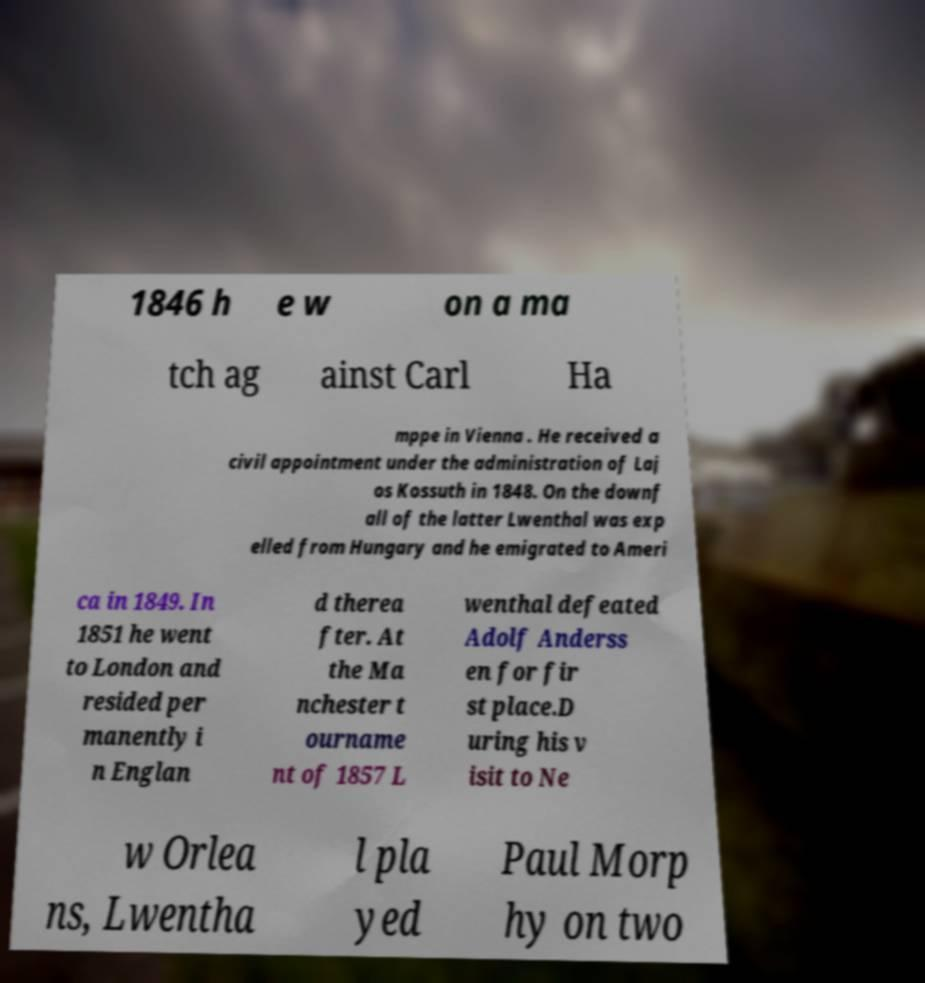Could you extract and type out the text from this image? 1846 h e w on a ma tch ag ainst Carl Ha mppe in Vienna . He received a civil appointment under the administration of Laj os Kossuth in 1848. On the downf all of the latter Lwenthal was exp elled from Hungary and he emigrated to Ameri ca in 1849. In 1851 he went to London and resided per manently i n Englan d therea fter. At the Ma nchester t ourname nt of 1857 L wenthal defeated Adolf Anderss en for fir st place.D uring his v isit to Ne w Orlea ns, Lwentha l pla yed Paul Morp hy on two 